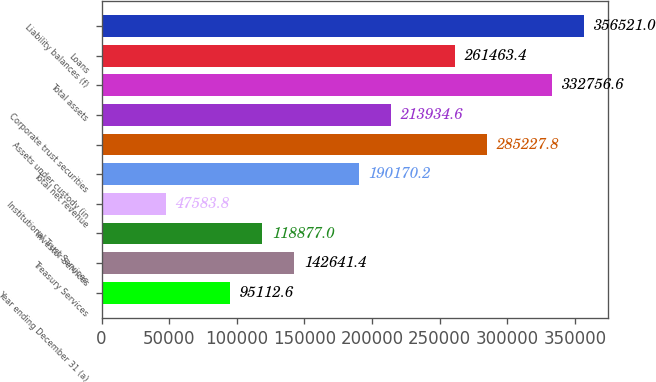Convert chart to OTSL. <chart><loc_0><loc_0><loc_500><loc_500><bar_chart><fcel>Year ending December 31 (a)<fcel>Treasury Services<fcel>Investor Services<fcel>Institutional Trust Services<fcel>Total net revenue<fcel>Assets under custody (in<fcel>Corporate trust securities<fcel>Total assets<fcel>Loans<fcel>Liability balances (f)<nl><fcel>95112.6<fcel>142641<fcel>118877<fcel>47583.8<fcel>190170<fcel>285228<fcel>213935<fcel>332757<fcel>261463<fcel>356521<nl></chart> 